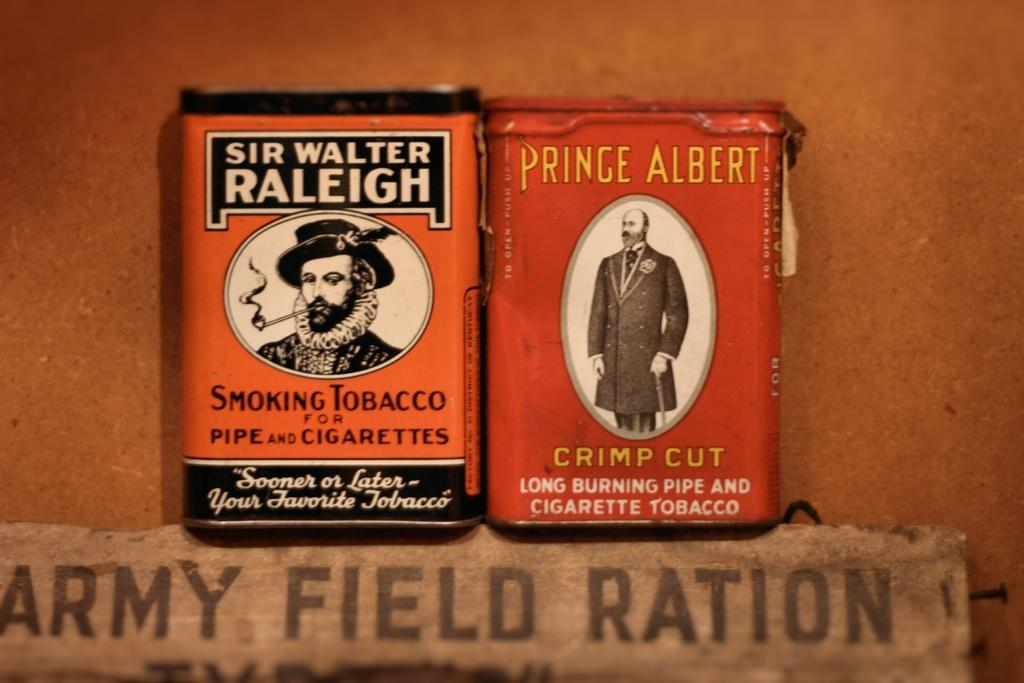Provide a one-sentence caption for the provided image. Sir Walter Raleigh cigarettes placed next to a Prince Albert box of cigarettes. 